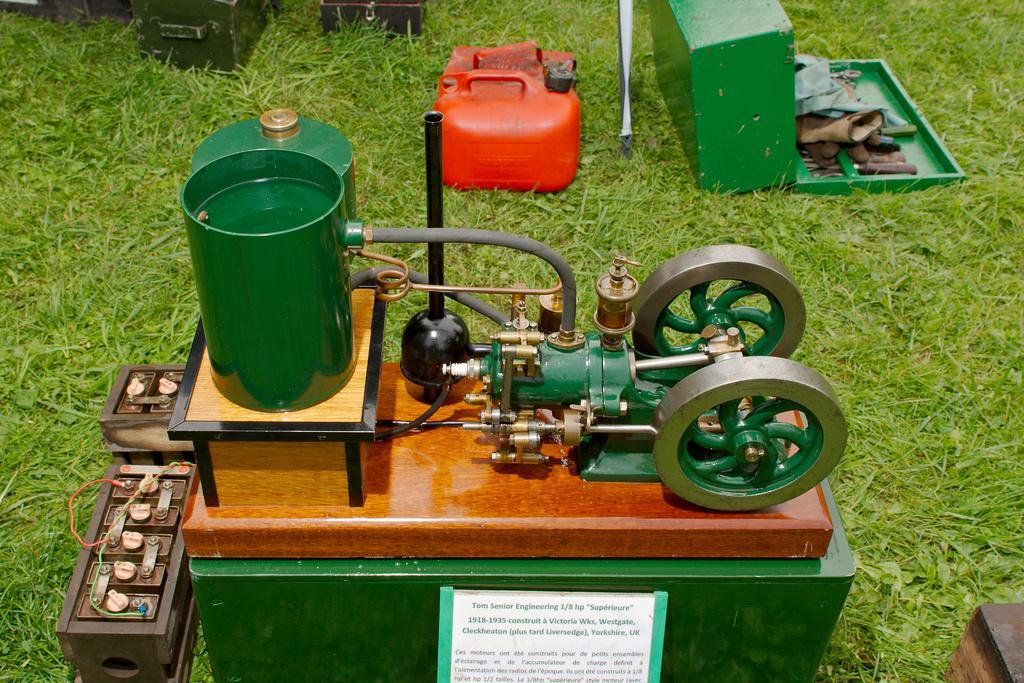Can you describe this image briefly? In this image there is a machine, tool box and red color container on the grass, beside them there are some other things. 